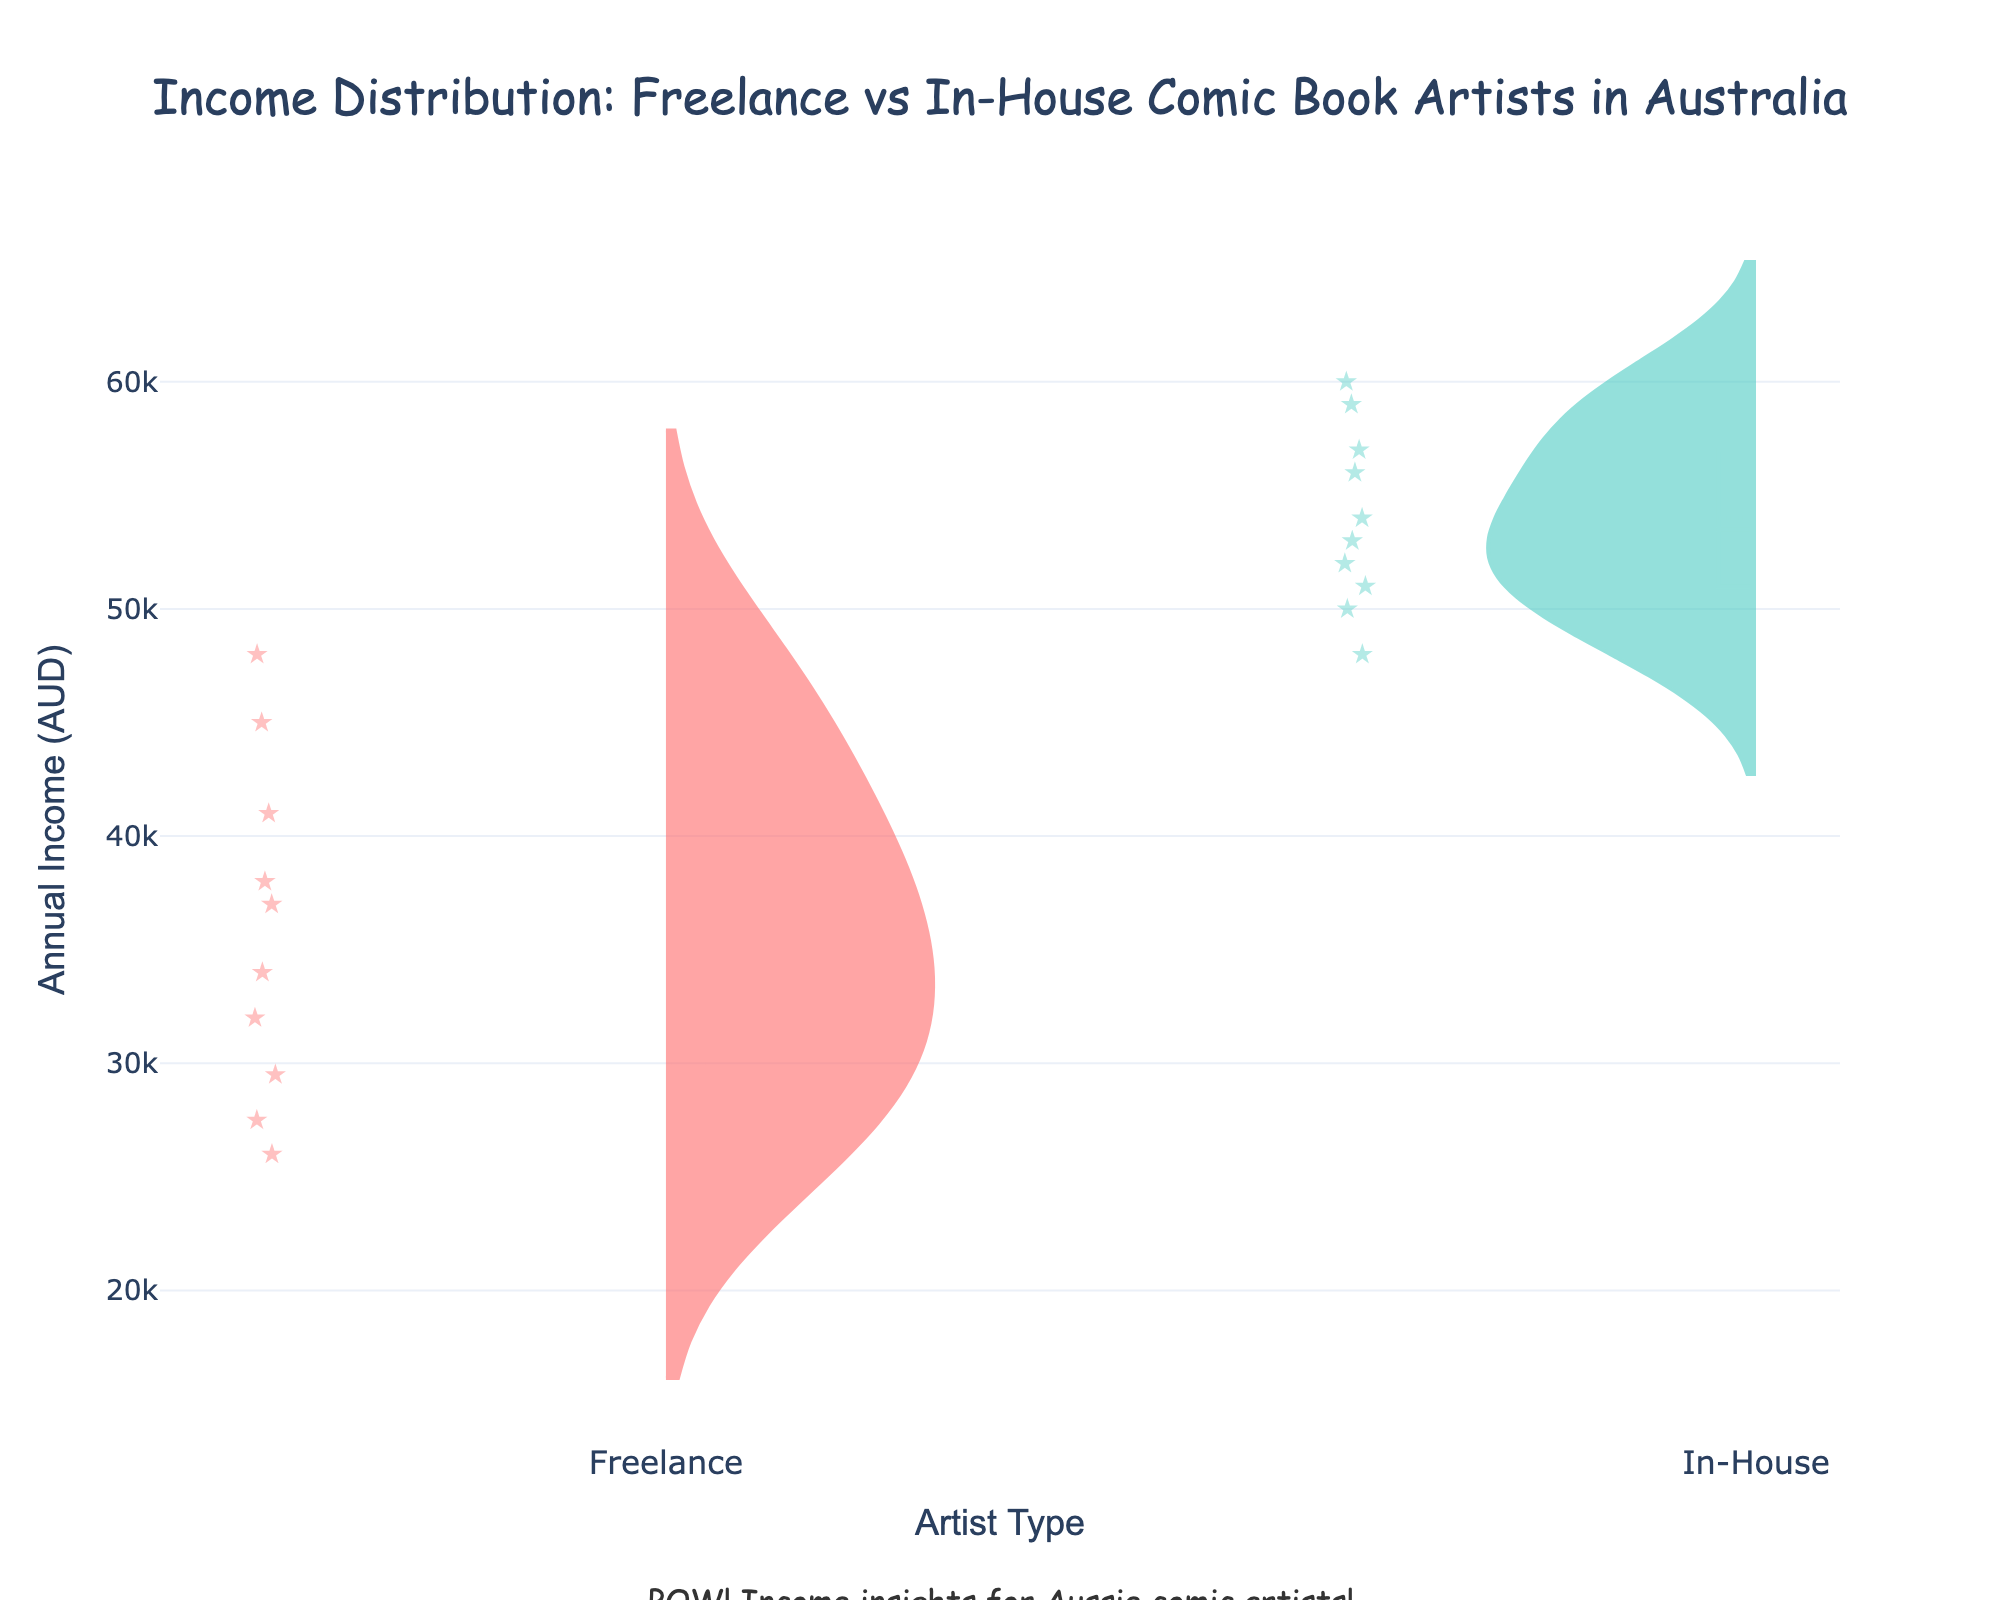What's the title of the figure? The title is located at the top of the figure, providing a brief description of the content
Answer: Income Distribution: Freelance vs In-House Comic Book Artists in Australia What are the artist types being compared in the figure? The artist types are labeled on the x-axis of the figure, showing the two categories being compared
Answer: Freelance and In-House Which artist type tends to have higher incomes? By visually comparing the density and the placement of the distributions, the In-House artists have higher median and overall higher income values
Answer: In-House What is the approximate median income for Freelance artists? The median is indicated by the dashed line in the middle of the violin plot for Freelance artists
Answer: 34,000 AUD What is the approximate median income for In-House artists? The median is indicated by the dashed line in the middle of the violin plot for In-House artists
Answer: 52,000 AUD Which artist type shows a wider spread of income values? The spread of income values is shown by the width and range of the violin plot; wider and taller plots indicate a larger spread
Answer: Freelance How do the mean incomes compare between Freelance and In-House artists? Mean income is shown by the solid line within the violin plots for each artist type; compare their vertical positions
Answer: The mean income for In-House artists is higher What insights does the figure provide about the income variability between the two types of artists? Compare the spread (width and height) of both violin plots; wider plots indicate more variability, while narrower plots indicate less variability
Answer: Freelance artists show more variability in income than In-House artists Based on the figure, which artist type might be more financially stable? The narrower spread of the In-House violin plot suggests more consistent income levels compared to the Freelance plot
Answer: In-House 